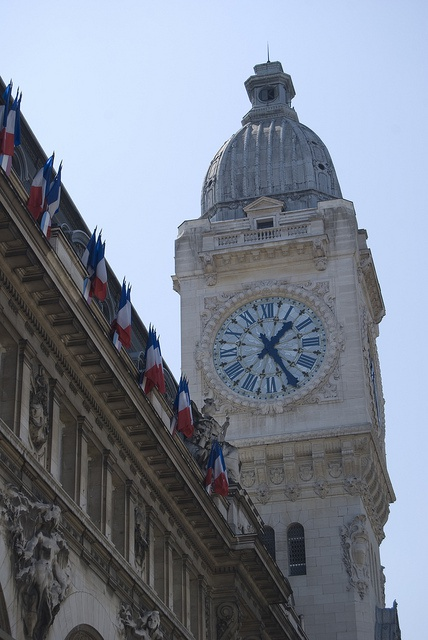Describe the objects in this image and their specific colors. I can see clock in lavender, gray, and navy tones and clock in lavender, gray, black, and darkblue tones in this image. 